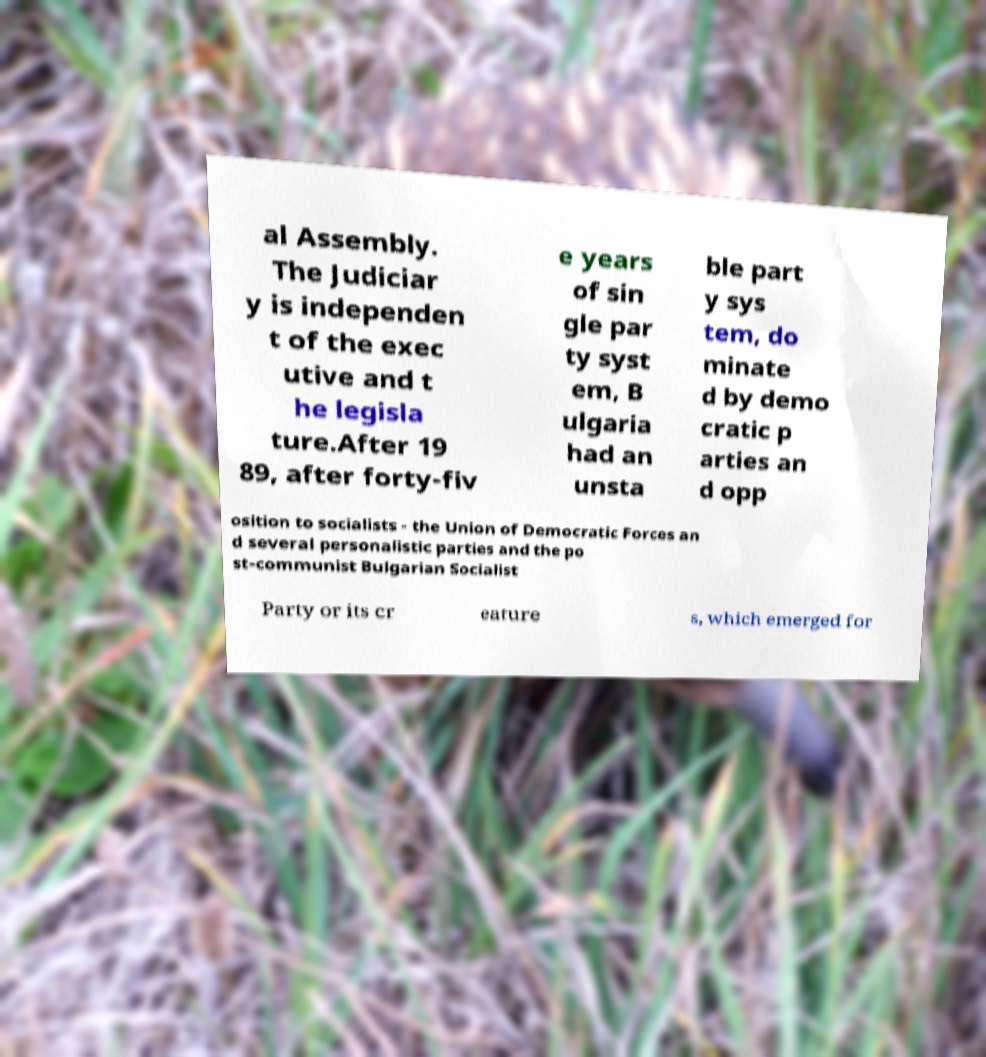Please read and relay the text visible in this image. What does it say? al Assembly. The Judiciar y is independen t of the exec utive and t he legisla ture.After 19 89, after forty-fiv e years of sin gle par ty syst em, B ulgaria had an unsta ble part y sys tem, do minate d by demo cratic p arties an d opp osition to socialists - the Union of Democratic Forces an d several personalistic parties and the po st-communist Bulgarian Socialist Party or its cr eature s, which emerged for 